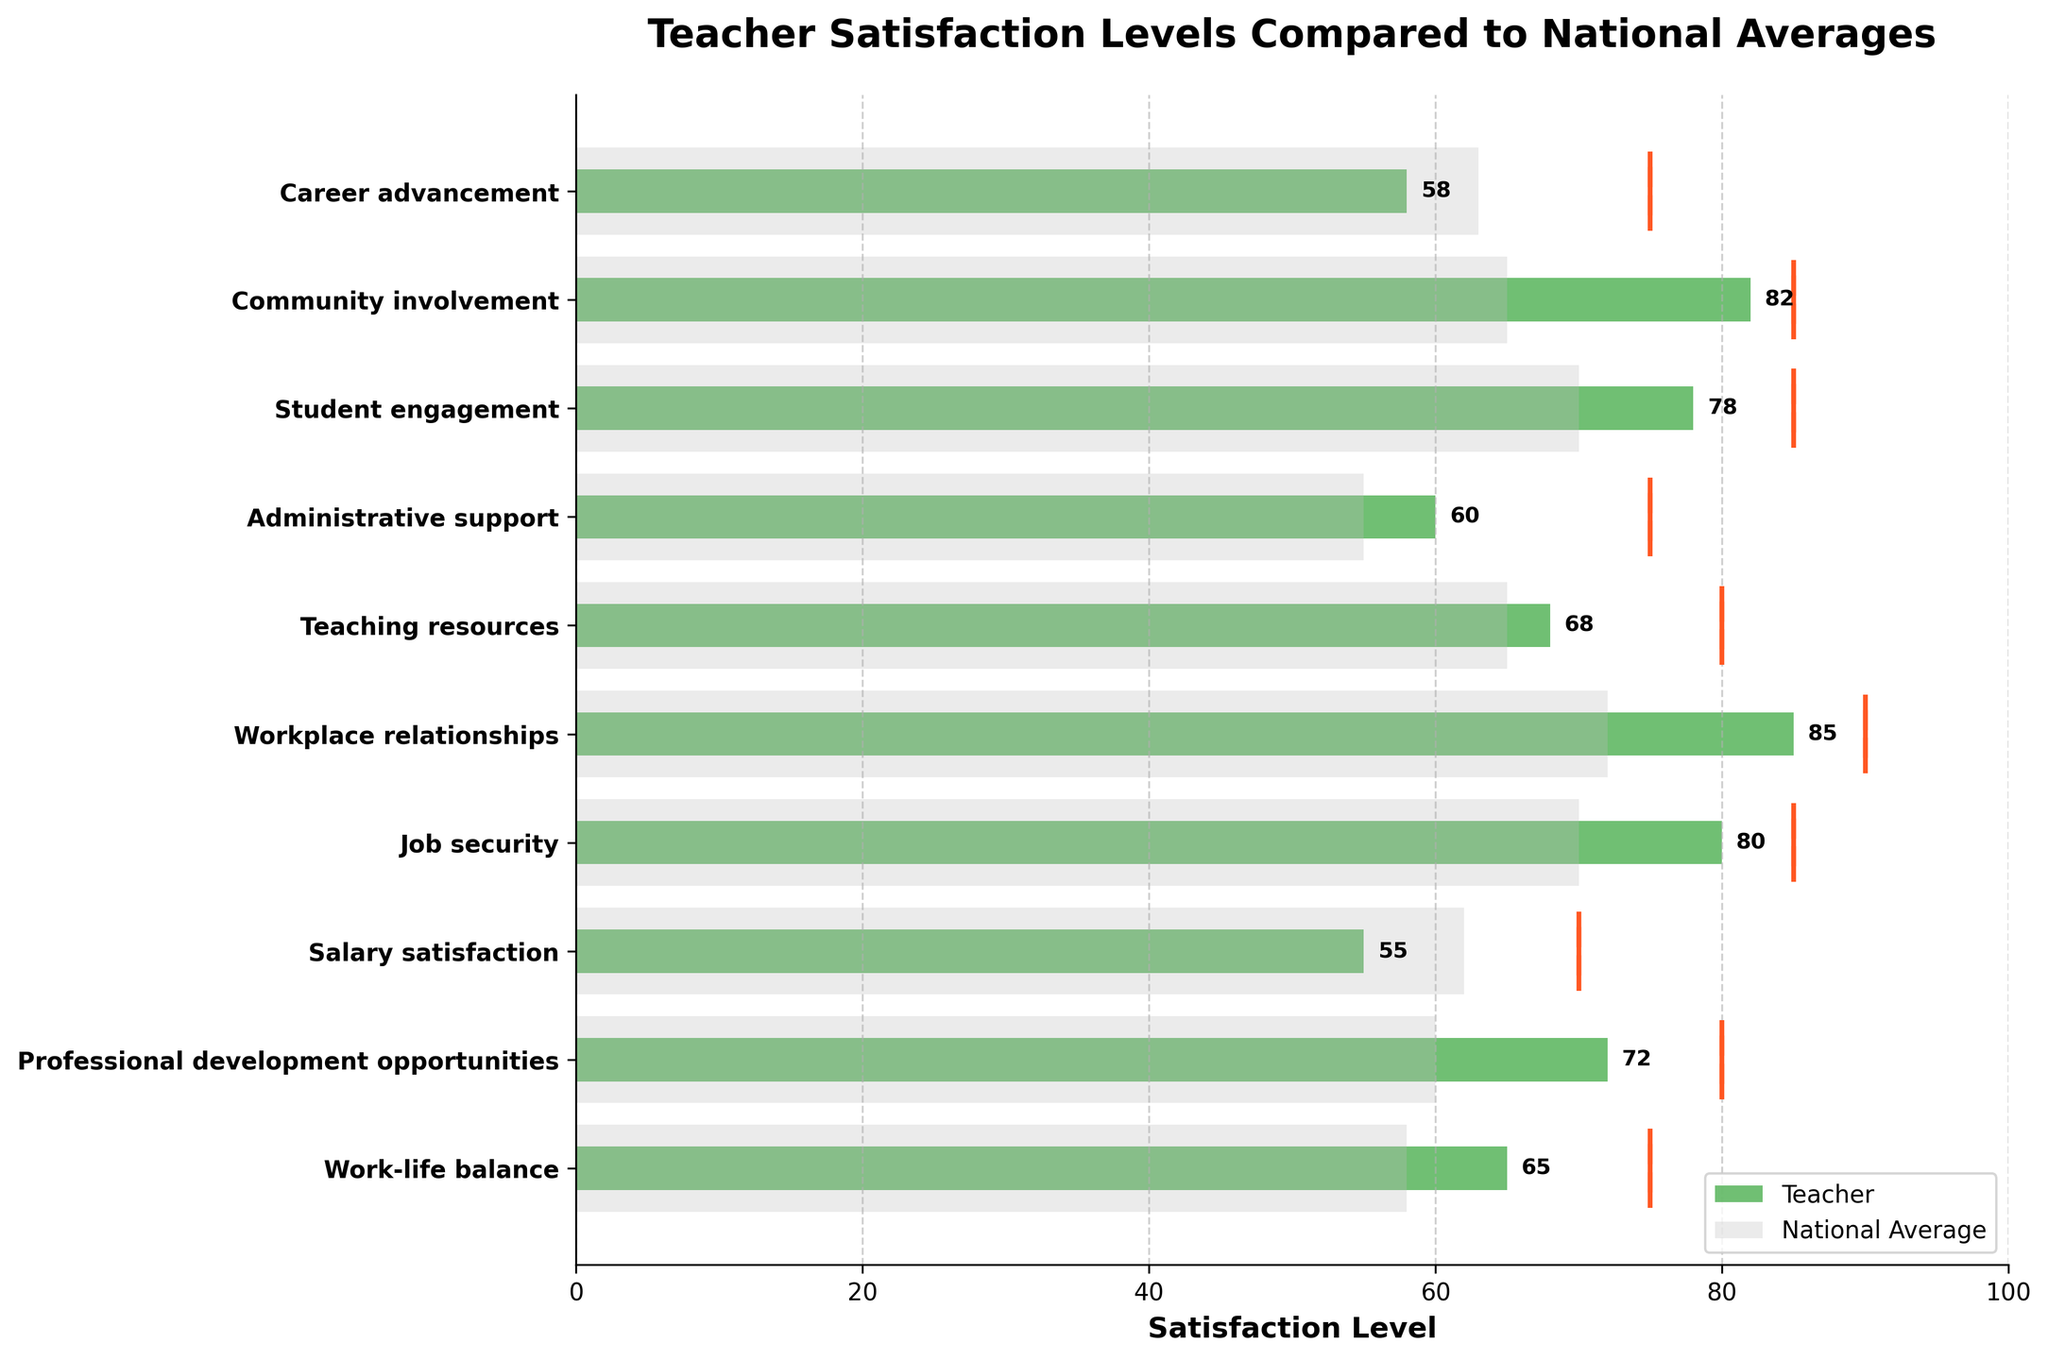What is the title of the chart? The title is usually displayed at the top of the chart. Look at the text written in bold at the very top of the figure.
Answer: Teacher Satisfaction Levels Compared to National Averages Which aspect has the highest teacher satisfaction score? To find the highest score, compare the values for each aspect. Look at the length of the green bars labeled for teachers and identify the one that stretches the farthest to the right.
Answer: Workplace relationships What is the teacher satisfaction level for Work-life balance? Locate the green bar corresponding to the "Work-life balance" aspect and read the value at the end of the bar.
Answer: 65 How does the teacher satisfaction for Salary satisfaction compare to the national average? Compare the lengths of the green bar (teacher) and the gray bar (national average) for Salary satisfaction. The green bar is shorter than the gray bar.
Answer: It is lower What aspects have teacher satisfaction levels greater than the national average? Identify the aspects where the green bar (teacher) is longer than the gray bar (national average). Check each pair of bars for all aspects.
Answer: Work-life balance, Professional development opportunities, Job security, Workplace relationships, Teaching resources, Administrative support, Student engagement, Community involvement How far is the teacher satisfaction level for Salary satisfaction from the target? Subtract the teacher score for Salary satisfaction (55) from its target (70).
Answer: 15 units Which aspect is closest to its target satisfaction level for teachers? For each aspect, find the absolute difference between the teacher's score and the target. Identify the smallest difference.
Answer: Community involvement What is the average teacher satisfaction level across all aspects? Sum up all teacher satisfaction scores and divide by the number of aspects (10). (65 + 72 + 55 + 80 + 85 + 68 + 60 + 78 + 82 + 58) = 703, then 703 / 10 = 70.3
Answer: 70.3 Which aspects have targets higher than both the teacher satisfaction level and the national average? Identify the aspects where the target exceeds both the teacher’s score and the national average score. Compare targets with both sets of scores for all aspects.
Answer: Work-life balance, Professional development opportunities, Salary satisfaction, Teaching resources, Administrative support, Career advancement 